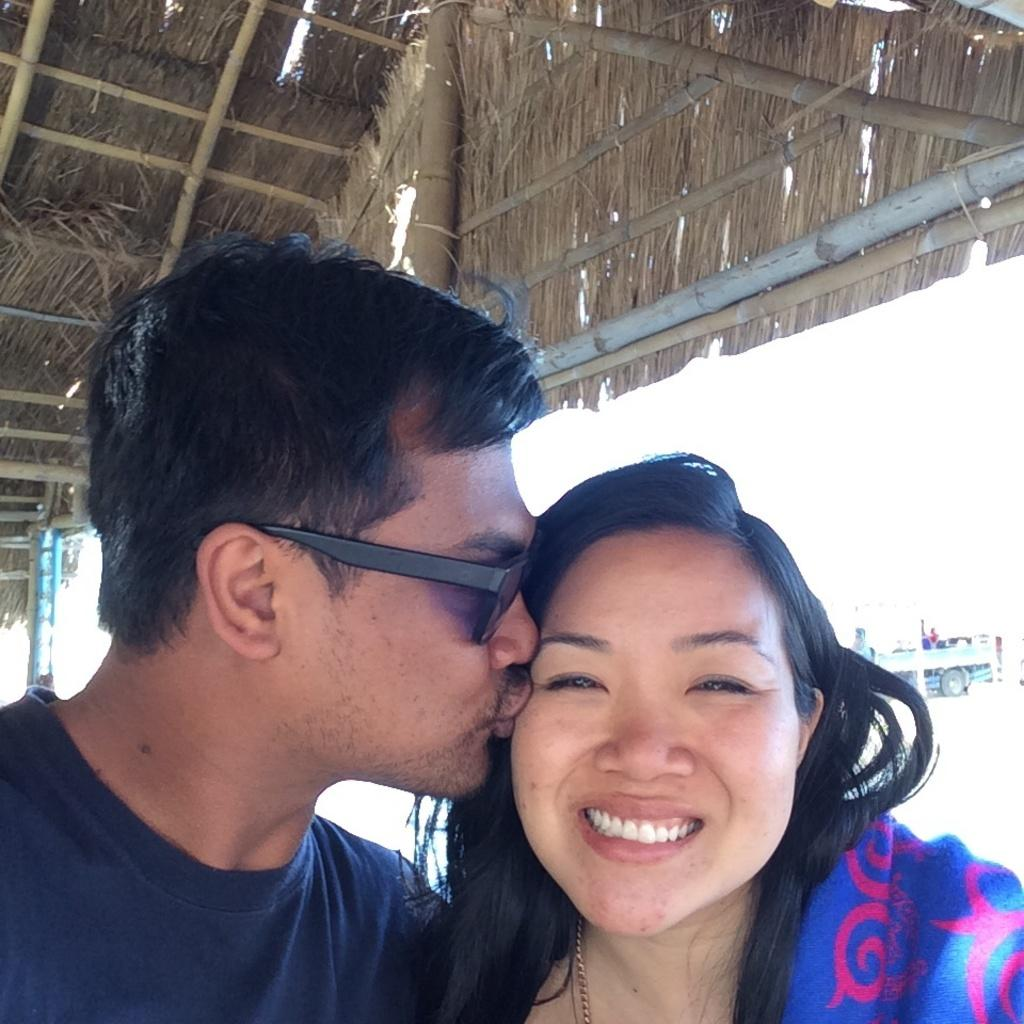Who can be seen in the image? There is a man and a woman in the image. What is the woman doing in the image? The woman is smiling in the image. What can be seen in the background of the image? There is a truck and a roof in the background of the image. What type of bell can be heard ringing in the image? There is no bell present in the image, and therefore no sound can be heard. Can you tell me which vein the man is pointing to in the image? There is no mention of the man pointing to any vein in the image. 